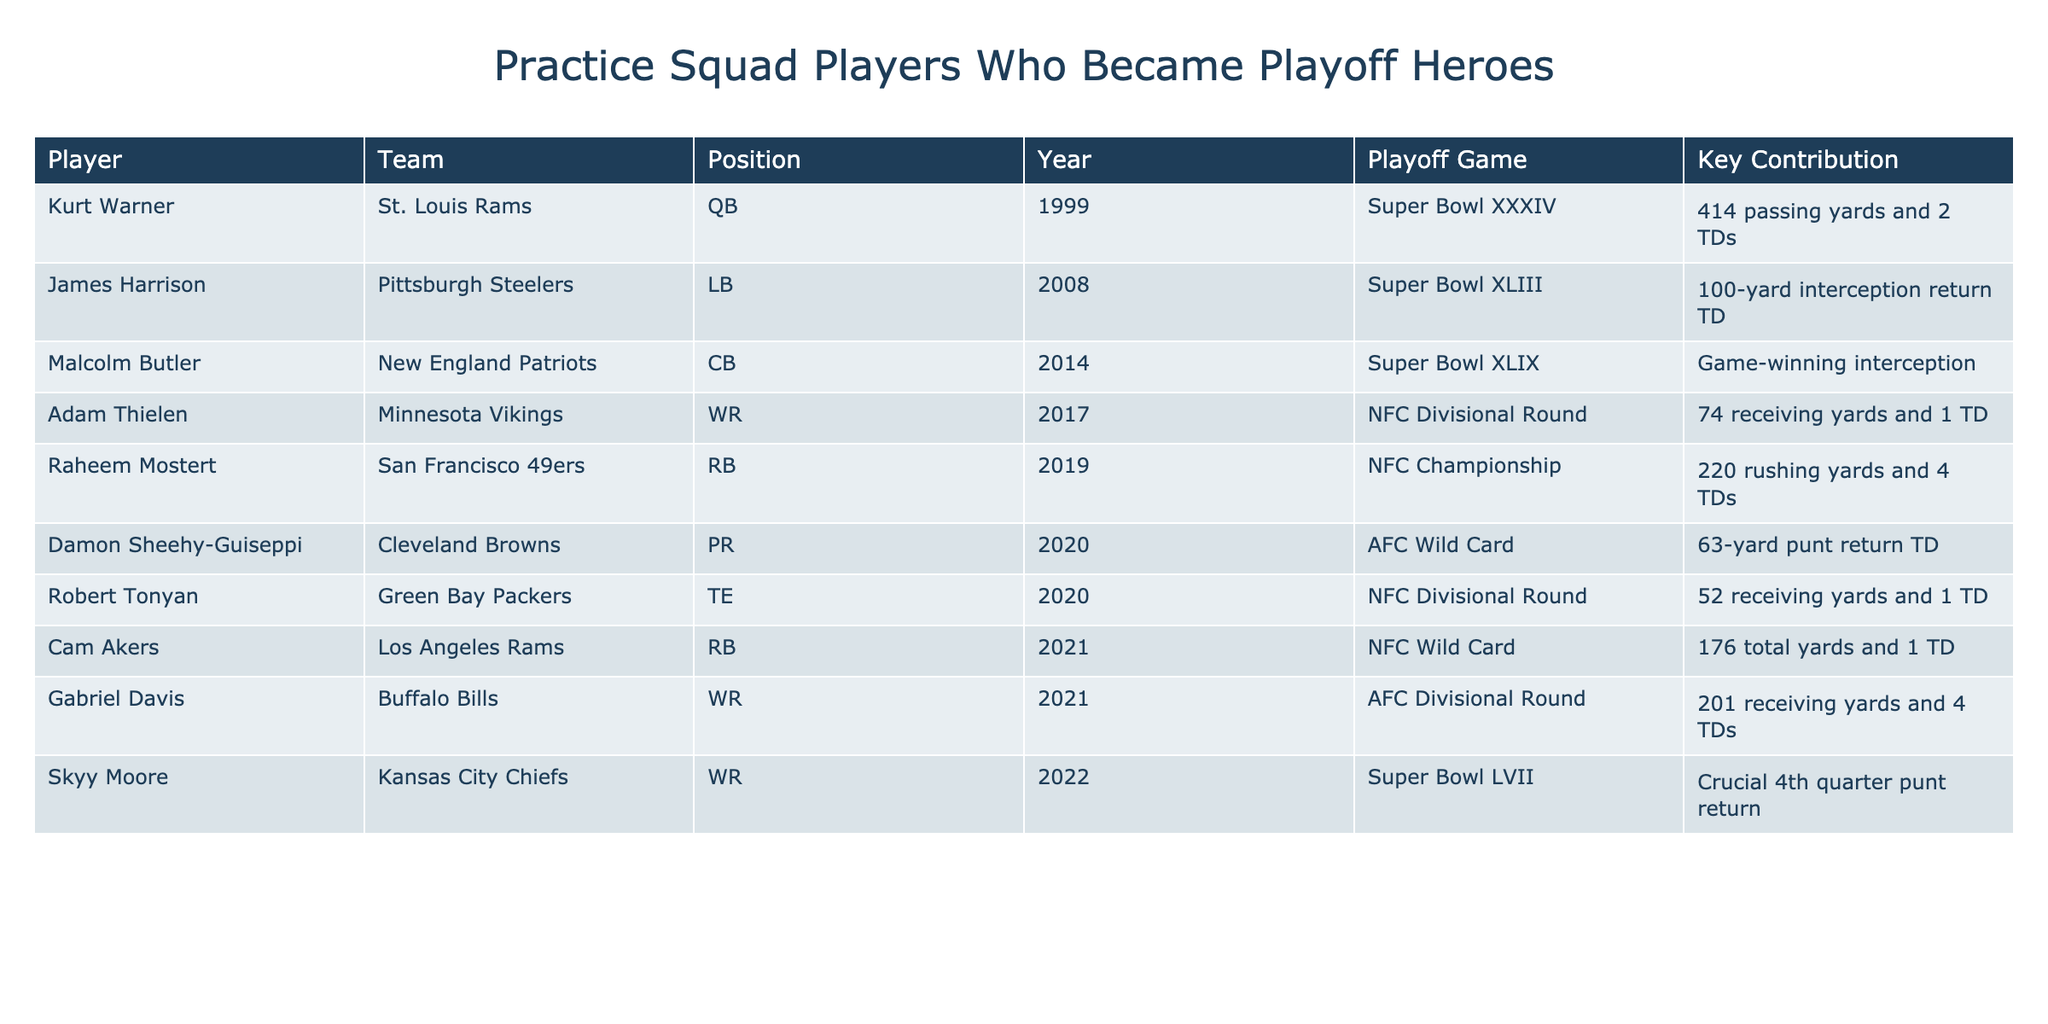What team did Kurt Warner play for when he had his key playoff contribution? The table lists Kurt Warner as playing for the St. Louis Rams when he contributed 414 passing yards and 2 TDs in Super Bowl XXXIV.
Answer: St. Louis Rams Which player recorded a 100-yard interception return touchdown in the playoffs? The data shows that James Harrison recorded a 100-yard interception return TD in Super Bowl XLIII.
Answer: James Harrison In what year did Raheem Mostert achieve 220 rushing yards in a playoff game? According to the table, Raheem Mostert achieved this in the NFC Championship game in 2019.
Answer: 2019 How many total yards did Cam Akers gain in the NFC Wild Card game? The table indicates that Cam Akers gained 176 total yards in the NFC Wild Card game in 2021.
Answer: 176 total yards Which player had the highest receiving yards in a playoff game according to this table? Gabriel Davis had the highest receiving yards with 201 in the AFC Divisional Round in 2021.
Answer: Gabriel Davis Did any players on the list contribute in a Super Bowl? The table includes players who contributed in Super Bowls, such as Kurt Warner and James Harrison.
Answer: Yes Which position had the most standout performances? Analyzing the contributions, both quarterbacks and wide receivers seem to have multiple impactful performances, but wide receivers (Adam Thielen, Gabriel Davis) have higher total contributions in terms of touchdowns and yardage combined.
Answer: Wide receivers What is the combined total of rushing yards contributed by Raheem Mostert and Cam Akers? Raheem Mostert had 220 rushing yards, and Cam Akers had a portion of his yards as rushing. Summing them gives: 220 + (Cam Akers' rushing yards are part of his total). However, since it lists total yards, we can't definitively double-count without knowing his rushing split.
Answer: Can’t determine precisely If you consider only the Super Bowl performances, how many touchdown contributions were there? Referring to the table, Kurt Warner (2 TDs) and James Harrison (1 TD) each had contributions resulting in touchdowns during their Super Bowl appearances. This totals to 3 TD contributions from Super Bowl games.
Answer: 3 TD contributions Who had the unique role of punt return and scored in a playoff game? The data shows that Damon Sheehy-Guiseppi played as a punt returner and scored with a 63-yard punt return TD in the AFC Wild Card game in 2020.
Answer: Damon Sheehy-Guiseppi 